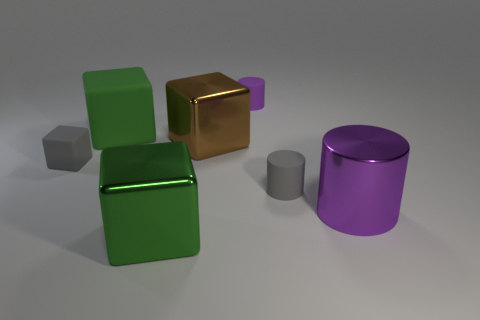Do the metal object in front of the big purple metallic object and the rubber cube that is right of the small cube have the same color?
Your response must be concise. Yes. How many other things are there of the same color as the metal cylinder?
Provide a short and direct response. 1. There is another large thing that is the same color as the large matte object; what material is it?
Offer a terse response. Metal. Are there any shiny things that have the same color as the big matte object?
Keep it short and to the point. Yes. What material is the gray thing that is the same shape as the purple rubber thing?
Make the answer very short. Rubber. Does the purple cylinder right of the gray rubber cylinder have the same size as the brown cube?
Offer a very short reply. Yes. How many shiny objects are either purple cylinders or small gray things?
Your answer should be compact. 1. What is the material of the tiny object that is in front of the brown shiny thing and to the left of the small gray rubber cylinder?
Provide a short and direct response. Rubber. Do the tiny purple object and the small block have the same material?
Ensure brevity in your answer.  Yes. What size is the thing that is both in front of the brown cube and behind the gray cylinder?
Your answer should be very brief. Small. 